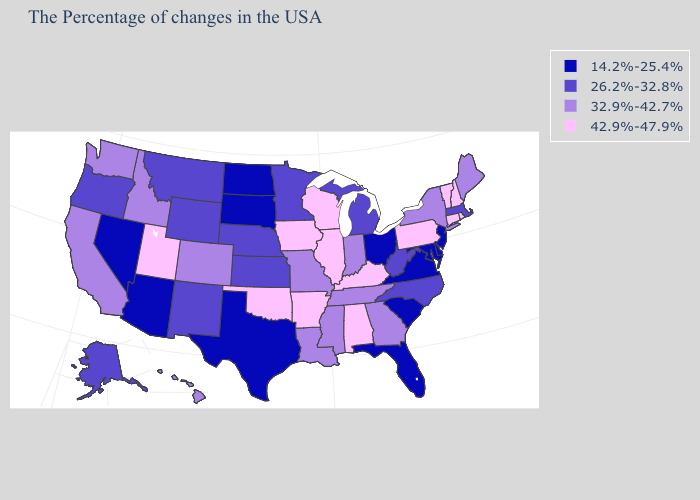What is the value of Mississippi?
Keep it brief. 32.9%-42.7%. Name the states that have a value in the range 26.2%-32.8%?
Quick response, please. Massachusetts, North Carolina, West Virginia, Michigan, Minnesota, Kansas, Nebraska, Wyoming, New Mexico, Montana, Oregon, Alaska. What is the lowest value in the West?
Give a very brief answer. 14.2%-25.4%. Name the states that have a value in the range 26.2%-32.8%?
Short answer required. Massachusetts, North Carolina, West Virginia, Michigan, Minnesota, Kansas, Nebraska, Wyoming, New Mexico, Montana, Oregon, Alaska. Does the map have missing data?
Answer briefly. No. Name the states that have a value in the range 42.9%-47.9%?
Be succinct. Rhode Island, New Hampshire, Vermont, Connecticut, Pennsylvania, Kentucky, Alabama, Wisconsin, Illinois, Arkansas, Iowa, Oklahoma, Utah. What is the lowest value in the USA?
Keep it brief. 14.2%-25.4%. Which states have the lowest value in the Northeast?
Write a very short answer. New Jersey. Which states have the highest value in the USA?
Concise answer only. Rhode Island, New Hampshire, Vermont, Connecticut, Pennsylvania, Kentucky, Alabama, Wisconsin, Illinois, Arkansas, Iowa, Oklahoma, Utah. Name the states that have a value in the range 14.2%-25.4%?
Write a very short answer. New Jersey, Delaware, Maryland, Virginia, South Carolina, Ohio, Florida, Texas, South Dakota, North Dakota, Arizona, Nevada. What is the value of Iowa?
Keep it brief. 42.9%-47.9%. Does Alaska have a lower value than Hawaii?
Keep it brief. Yes. What is the value of West Virginia?
Answer briefly. 26.2%-32.8%. Which states have the lowest value in the USA?
Keep it brief. New Jersey, Delaware, Maryland, Virginia, South Carolina, Ohio, Florida, Texas, South Dakota, North Dakota, Arizona, Nevada. What is the value of Mississippi?
Keep it brief. 32.9%-42.7%. 